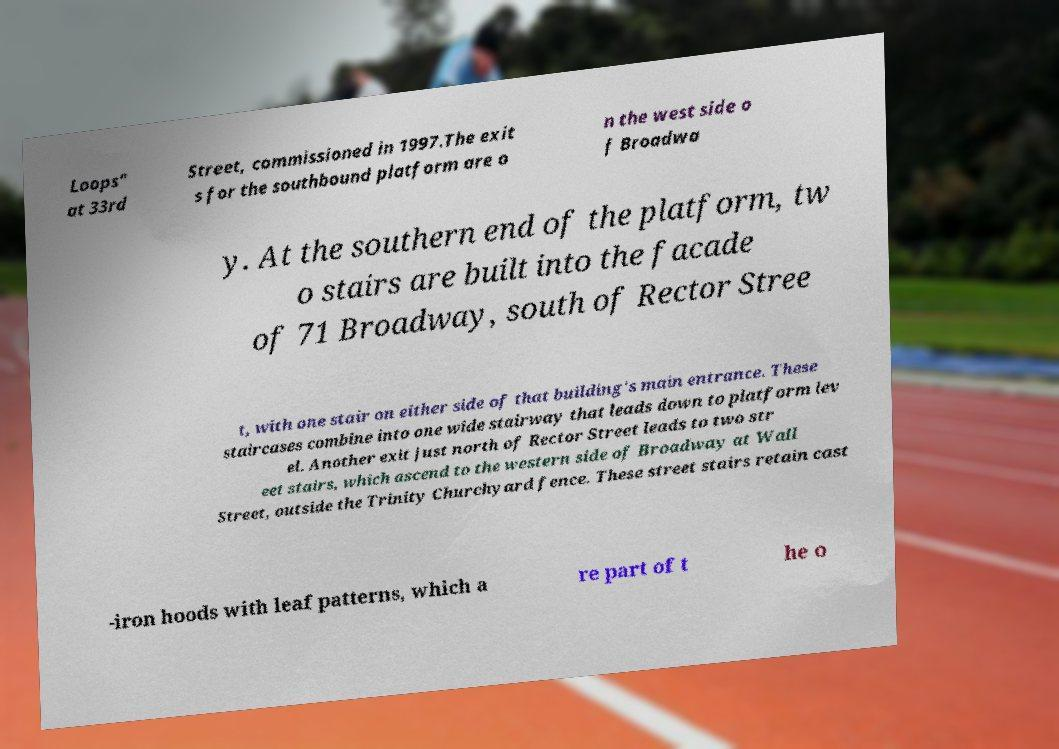Can you accurately transcribe the text from the provided image for me? Loops" at 33rd Street, commissioned in 1997.The exit s for the southbound platform are o n the west side o f Broadwa y. At the southern end of the platform, tw o stairs are built into the facade of 71 Broadway, south of Rector Stree t, with one stair on either side of that building's main entrance. These staircases combine into one wide stairway that leads down to platform lev el. Another exit just north of Rector Street leads to two str eet stairs, which ascend to the western side of Broadway at Wall Street, outside the Trinity Churchyard fence. These street stairs retain cast -iron hoods with leaf patterns, which a re part of t he o 